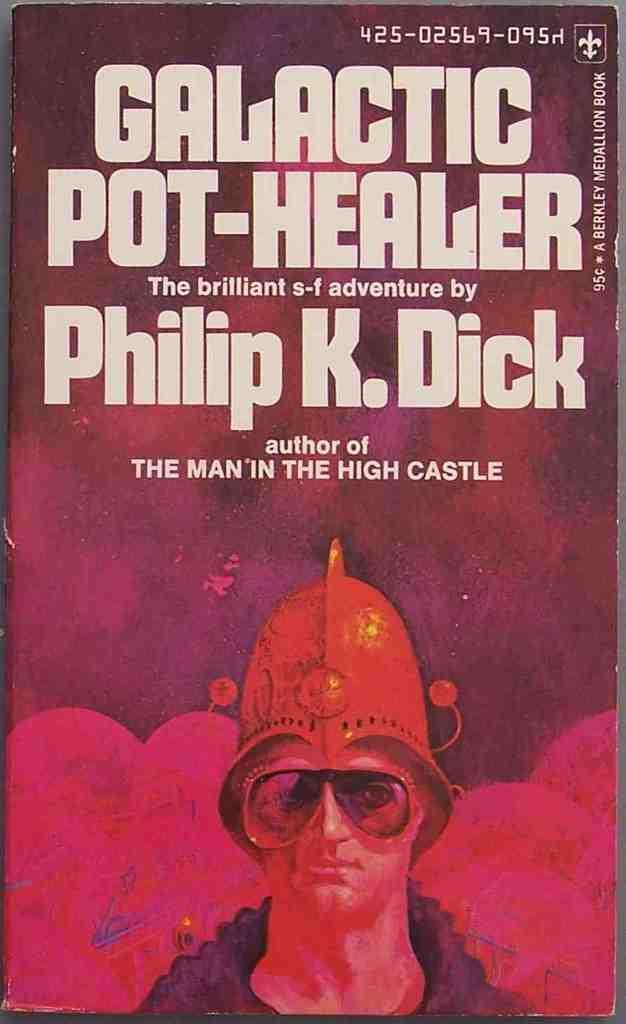Can you describe this image briefly? In this picture we can see a poster, here we can see a person and some text on it. 